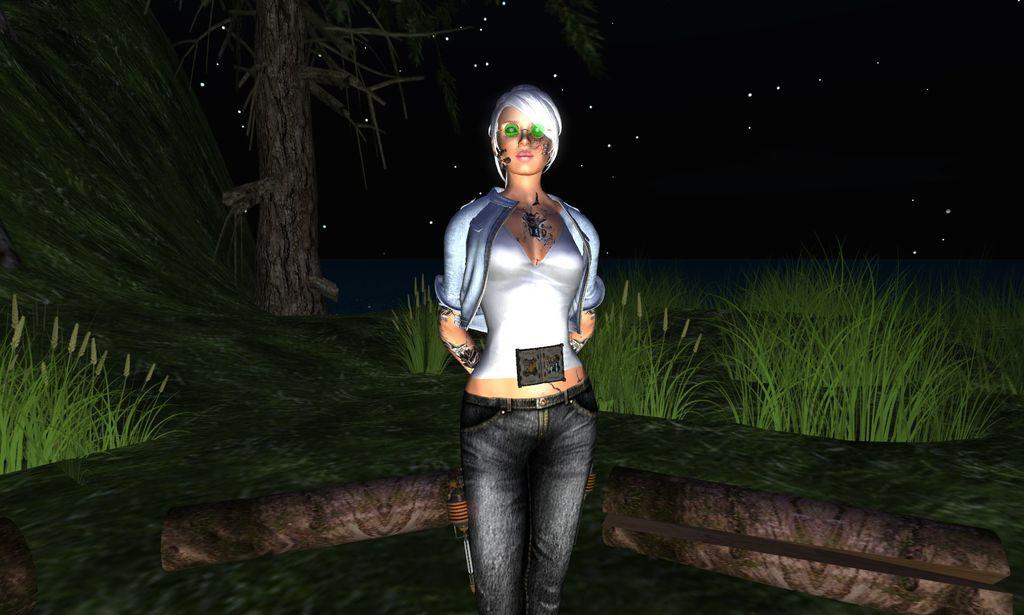What type of image is being described? The image is an animated picture. Can you describe the woman in the image? There is a woman standing in the image. What type of natural environment is visible in the image? There is grass and a tree visible in the image. How would you describe the background of the image? The background of the image is dark. What type of dirt can be seen on the church in the image? There is no church present in the image, so there is no dirt to be seen on it. 